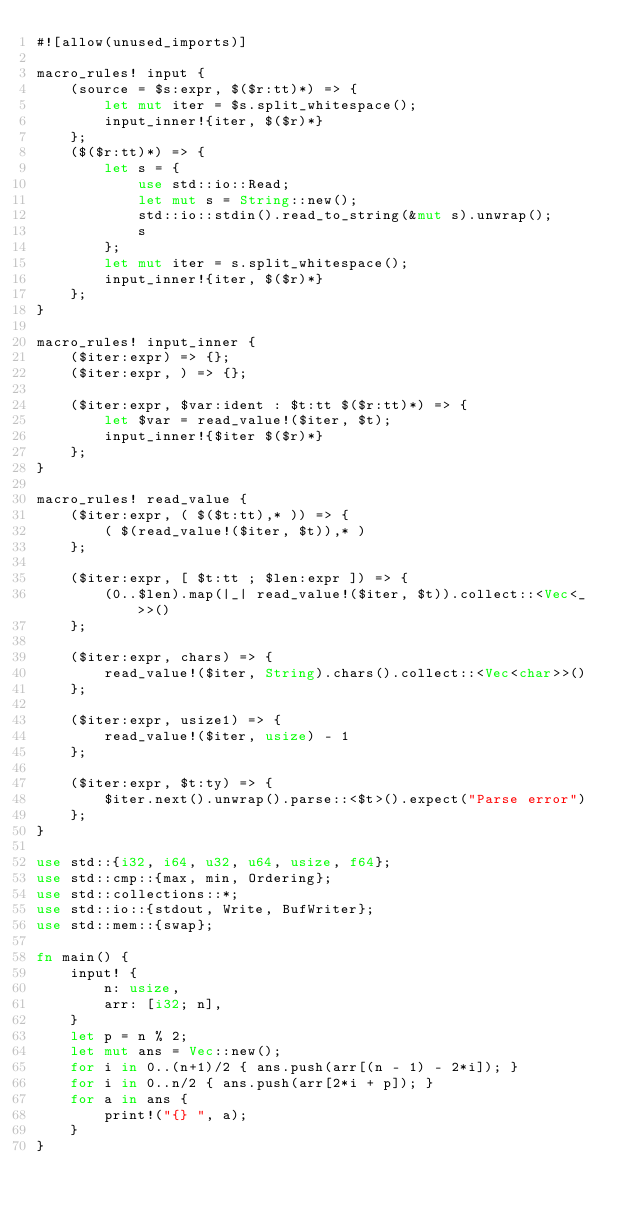Convert code to text. <code><loc_0><loc_0><loc_500><loc_500><_Rust_>#![allow(unused_imports)]

macro_rules! input {
    (source = $s:expr, $($r:tt)*) => {
        let mut iter = $s.split_whitespace();
        input_inner!{iter, $($r)*}
    };
    ($($r:tt)*) => {
        let s = {
            use std::io::Read;
            let mut s = String::new();
            std::io::stdin().read_to_string(&mut s).unwrap();
            s
        };
        let mut iter = s.split_whitespace();
        input_inner!{iter, $($r)*}
    };
}

macro_rules! input_inner {
    ($iter:expr) => {};
    ($iter:expr, ) => {};

    ($iter:expr, $var:ident : $t:tt $($r:tt)*) => {
        let $var = read_value!($iter, $t);
        input_inner!{$iter $($r)*}
    };
}

macro_rules! read_value {
    ($iter:expr, ( $($t:tt),* )) => {
        ( $(read_value!($iter, $t)),* )
    };

    ($iter:expr, [ $t:tt ; $len:expr ]) => {
        (0..$len).map(|_| read_value!($iter, $t)).collect::<Vec<_>>()
    };

    ($iter:expr, chars) => {
        read_value!($iter, String).chars().collect::<Vec<char>>()
    };

    ($iter:expr, usize1) => {
        read_value!($iter, usize) - 1
    };

    ($iter:expr, $t:ty) => {
        $iter.next().unwrap().parse::<$t>().expect("Parse error")
    };
}

use std::{i32, i64, u32, u64, usize, f64};
use std::cmp::{max, min, Ordering};
use std::collections::*;
use std::io::{stdout, Write, BufWriter};
use std::mem::{swap};

fn main() {
    input! {
        n: usize,
        arr: [i32; n],
    }
    let p = n % 2;
    let mut ans = Vec::new();
    for i in 0..(n+1)/2 { ans.push(arr[(n - 1) - 2*i]); }
    for i in 0..n/2 { ans.push(arr[2*i + p]); }
    for a in ans {
        print!("{} ", a);
    }
}
</code> 